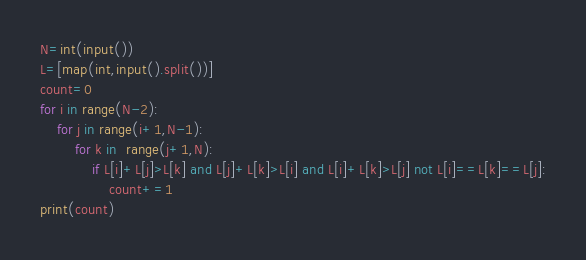Convert code to text. <code><loc_0><loc_0><loc_500><loc_500><_Python_>N=int(input())
L=[map(int,input().split())]
count=0
for i in range(N-2):
    for j in range(i+1,N-1):
        for k in  range(j+1,N):
            if L[i]+L[j]>L[k] and L[j]+L[k]>L[i] and L[i]+L[k]>L[j] not L[i]==L[k]==L[j]:
                count+=1
print(count)</code> 